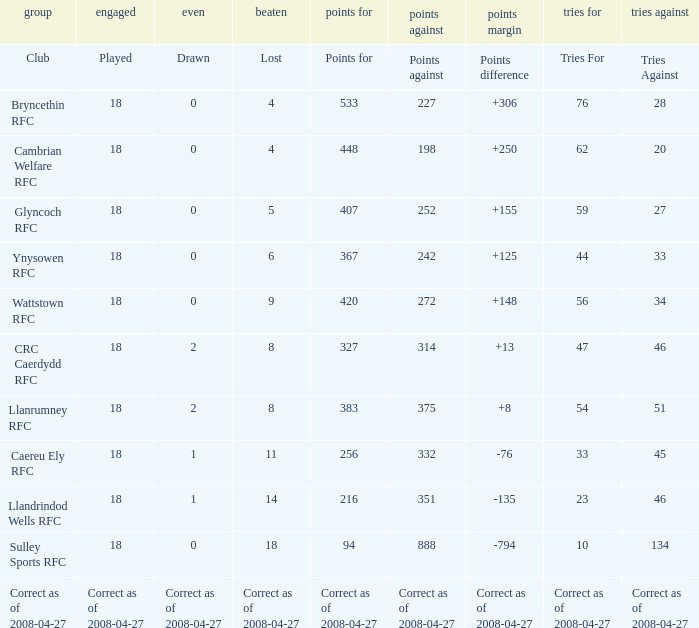What is the value for the item "Tries" when the value of the item "Played" is 18 and the value of the item "Points" is 375? 54.0. 